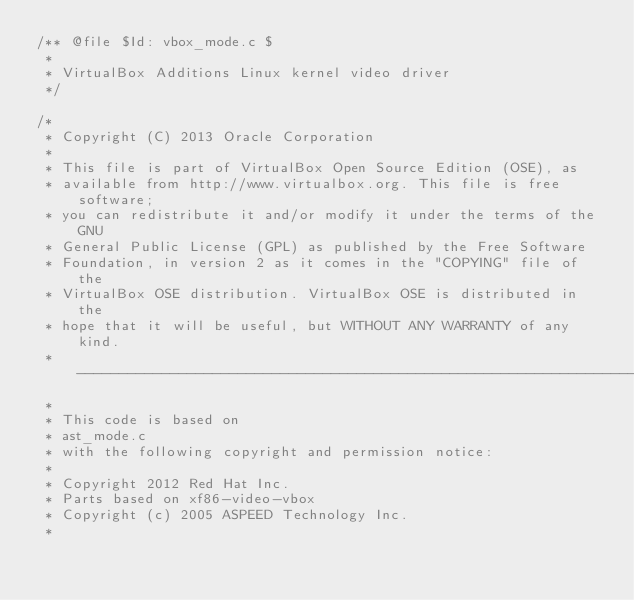Convert code to text. <code><loc_0><loc_0><loc_500><loc_500><_C_>/** @file $Id: vbox_mode.c $
 *
 * VirtualBox Additions Linux kernel video driver
 */

/*
 * Copyright (C) 2013 Oracle Corporation
 *
 * This file is part of VirtualBox Open Source Edition (OSE), as
 * available from http://www.virtualbox.org. This file is free software;
 * you can redistribute it and/or modify it under the terms of the GNU
 * General Public License (GPL) as published by the Free Software
 * Foundation, in version 2 as it comes in the "COPYING" file of the
 * VirtualBox OSE distribution. VirtualBox OSE is distributed in the
 * hope that it will be useful, but WITHOUT ANY WARRANTY of any kind.
 * --------------------------------------------------------------------
 *
 * This code is based on
 * ast_mode.c
 * with the following copyright and permission notice:
 *
 * Copyright 2012 Red Hat Inc.
 * Parts based on xf86-video-vbox
 * Copyright (c) 2005 ASPEED Technology Inc.
 *</code> 